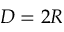<formula> <loc_0><loc_0><loc_500><loc_500>D = 2 R</formula> 